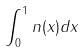Convert formula to latex. <formula><loc_0><loc_0><loc_500><loc_500>\int _ { 0 } ^ { 1 } n ( x ) d x</formula> 